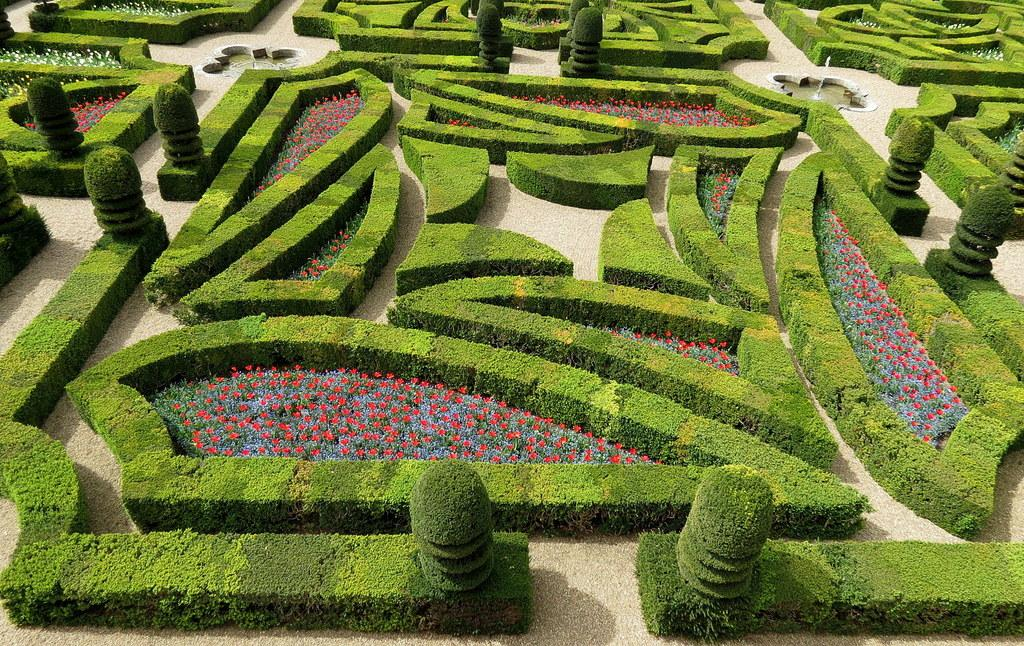What type of plant can be seen in the image? There is a flower plant in the image. Are there any other plants visible in the scene? Yes, there are other plants in the image. What kind of setting is depicted in the image? The scene appears to be a garden. What feature can be seen for walking in the garden? There is a path visible in the image. What additional feature can be found in the garden? There are water fountains in the image. How many girls are walking on the path in the image? There are no girls present in the image; it features of the garden are the main focus. 